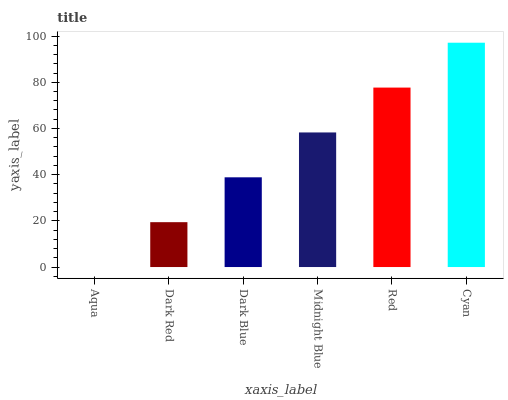Is Aqua the minimum?
Answer yes or no. Yes. Is Cyan the maximum?
Answer yes or no. Yes. Is Dark Red the minimum?
Answer yes or no. No. Is Dark Red the maximum?
Answer yes or no. No. Is Dark Red greater than Aqua?
Answer yes or no. Yes. Is Aqua less than Dark Red?
Answer yes or no. Yes. Is Aqua greater than Dark Red?
Answer yes or no. No. Is Dark Red less than Aqua?
Answer yes or no. No. Is Midnight Blue the high median?
Answer yes or no. Yes. Is Dark Blue the low median?
Answer yes or no. Yes. Is Dark Red the high median?
Answer yes or no. No. Is Aqua the low median?
Answer yes or no. No. 